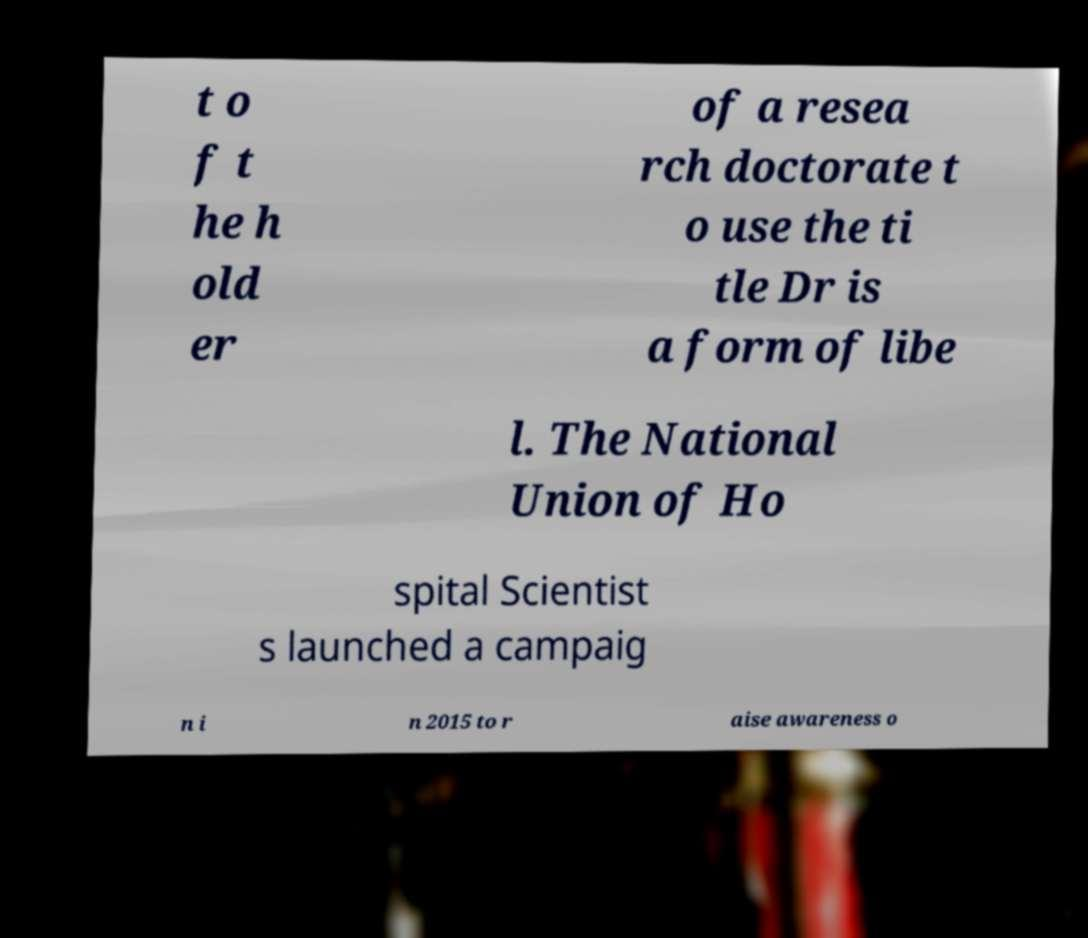Could you extract and type out the text from this image? t o f t he h old er of a resea rch doctorate t o use the ti tle Dr is a form of libe l. The National Union of Ho spital Scientist s launched a campaig n i n 2015 to r aise awareness o 